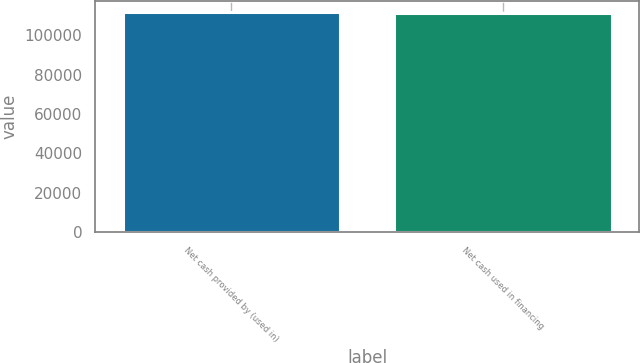Convert chart. <chart><loc_0><loc_0><loc_500><loc_500><bar_chart><fcel>Net cash provided by (used in)<fcel>Net cash used in financing<nl><fcel>112027<fcel>111380<nl></chart> 